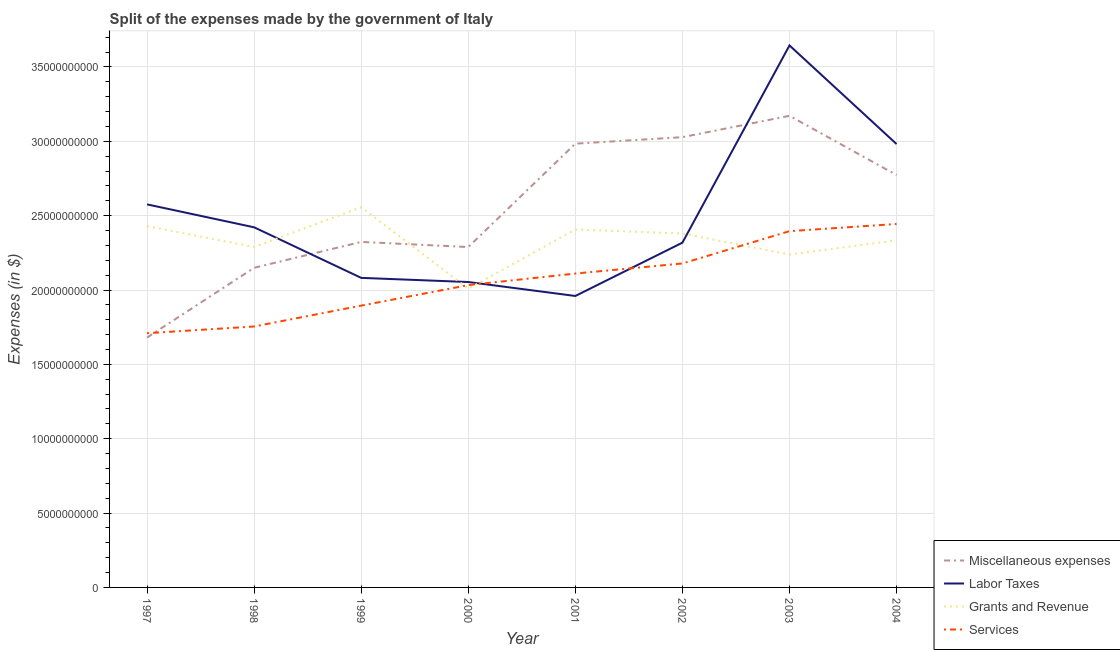Does the line corresponding to amount spent on miscellaneous expenses intersect with the line corresponding to amount spent on grants and revenue?
Ensure brevity in your answer.  Yes. Is the number of lines equal to the number of legend labels?
Your response must be concise. Yes. What is the amount spent on labor taxes in 2003?
Provide a short and direct response. 3.64e+1. Across all years, what is the maximum amount spent on miscellaneous expenses?
Offer a very short reply. 3.17e+1. Across all years, what is the minimum amount spent on grants and revenue?
Make the answer very short. 2.01e+1. In which year was the amount spent on miscellaneous expenses minimum?
Your response must be concise. 1997. What is the total amount spent on grants and revenue in the graph?
Make the answer very short. 1.86e+11. What is the difference between the amount spent on services in 1998 and that in 2001?
Offer a very short reply. -3.56e+09. What is the difference between the amount spent on miscellaneous expenses in 2000 and the amount spent on grants and revenue in 2001?
Make the answer very short. -1.18e+09. What is the average amount spent on labor taxes per year?
Provide a short and direct response. 2.50e+1. In the year 1999, what is the difference between the amount spent on services and amount spent on miscellaneous expenses?
Ensure brevity in your answer.  -4.28e+09. What is the ratio of the amount spent on miscellaneous expenses in 2000 to that in 2001?
Provide a short and direct response. 0.77. What is the difference between the highest and the second highest amount spent on services?
Keep it short and to the point. 4.83e+08. What is the difference between the highest and the lowest amount spent on grants and revenue?
Your answer should be very brief. 5.48e+09. Is the sum of the amount spent on miscellaneous expenses in 1999 and 2002 greater than the maximum amount spent on grants and revenue across all years?
Make the answer very short. Yes. Is it the case that in every year, the sum of the amount spent on grants and revenue and amount spent on services is greater than the sum of amount spent on labor taxes and amount spent on miscellaneous expenses?
Provide a succinct answer. No. Is the amount spent on miscellaneous expenses strictly less than the amount spent on services over the years?
Keep it short and to the point. No. How many lines are there?
Give a very brief answer. 4. How many years are there in the graph?
Offer a terse response. 8. Does the graph contain any zero values?
Offer a very short reply. No. Does the graph contain grids?
Ensure brevity in your answer.  Yes. How many legend labels are there?
Make the answer very short. 4. What is the title of the graph?
Offer a terse response. Split of the expenses made by the government of Italy. What is the label or title of the Y-axis?
Keep it short and to the point. Expenses (in $). What is the Expenses (in $) of Miscellaneous expenses in 1997?
Offer a terse response. 1.68e+1. What is the Expenses (in $) in Labor Taxes in 1997?
Keep it short and to the point. 2.58e+1. What is the Expenses (in $) in Grants and Revenue in 1997?
Give a very brief answer. 2.43e+1. What is the Expenses (in $) in Services in 1997?
Keep it short and to the point. 1.71e+1. What is the Expenses (in $) in Miscellaneous expenses in 1998?
Your response must be concise. 2.15e+1. What is the Expenses (in $) in Labor Taxes in 1998?
Ensure brevity in your answer.  2.42e+1. What is the Expenses (in $) of Grants and Revenue in 1998?
Offer a very short reply. 2.29e+1. What is the Expenses (in $) in Services in 1998?
Make the answer very short. 1.75e+1. What is the Expenses (in $) of Miscellaneous expenses in 1999?
Ensure brevity in your answer.  2.32e+1. What is the Expenses (in $) of Labor Taxes in 1999?
Your answer should be very brief. 2.08e+1. What is the Expenses (in $) of Grants and Revenue in 1999?
Provide a short and direct response. 2.56e+1. What is the Expenses (in $) in Services in 1999?
Ensure brevity in your answer.  1.89e+1. What is the Expenses (in $) in Miscellaneous expenses in 2000?
Offer a terse response. 2.29e+1. What is the Expenses (in $) in Labor Taxes in 2000?
Offer a very short reply. 2.05e+1. What is the Expenses (in $) in Grants and Revenue in 2000?
Offer a terse response. 2.01e+1. What is the Expenses (in $) of Services in 2000?
Ensure brevity in your answer.  2.03e+1. What is the Expenses (in $) of Miscellaneous expenses in 2001?
Your answer should be compact. 2.98e+1. What is the Expenses (in $) in Labor Taxes in 2001?
Offer a terse response. 1.96e+1. What is the Expenses (in $) in Grants and Revenue in 2001?
Provide a short and direct response. 2.41e+1. What is the Expenses (in $) in Services in 2001?
Offer a very short reply. 2.11e+1. What is the Expenses (in $) in Miscellaneous expenses in 2002?
Give a very brief answer. 3.03e+1. What is the Expenses (in $) of Labor Taxes in 2002?
Offer a very short reply. 2.32e+1. What is the Expenses (in $) of Grants and Revenue in 2002?
Give a very brief answer. 2.38e+1. What is the Expenses (in $) in Services in 2002?
Your response must be concise. 2.18e+1. What is the Expenses (in $) in Miscellaneous expenses in 2003?
Ensure brevity in your answer.  3.17e+1. What is the Expenses (in $) of Labor Taxes in 2003?
Provide a succinct answer. 3.64e+1. What is the Expenses (in $) of Grants and Revenue in 2003?
Your answer should be compact. 2.24e+1. What is the Expenses (in $) in Services in 2003?
Provide a succinct answer. 2.40e+1. What is the Expenses (in $) of Miscellaneous expenses in 2004?
Offer a terse response. 2.77e+1. What is the Expenses (in $) of Labor Taxes in 2004?
Offer a terse response. 2.98e+1. What is the Expenses (in $) in Grants and Revenue in 2004?
Make the answer very short. 2.33e+1. What is the Expenses (in $) of Services in 2004?
Keep it short and to the point. 2.44e+1. Across all years, what is the maximum Expenses (in $) in Miscellaneous expenses?
Your answer should be very brief. 3.17e+1. Across all years, what is the maximum Expenses (in $) of Labor Taxes?
Offer a terse response. 3.64e+1. Across all years, what is the maximum Expenses (in $) in Grants and Revenue?
Make the answer very short. 2.56e+1. Across all years, what is the maximum Expenses (in $) of Services?
Give a very brief answer. 2.44e+1. Across all years, what is the minimum Expenses (in $) in Miscellaneous expenses?
Your response must be concise. 1.68e+1. Across all years, what is the minimum Expenses (in $) of Labor Taxes?
Your answer should be very brief. 1.96e+1. Across all years, what is the minimum Expenses (in $) in Grants and Revenue?
Offer a terse response. 2.01e+1. Across all years, what is the minimum Expenses (in $) in Services?
Provide a short and direct response. 1.71e+1. What is the total Expenses (in $) in Miscellaneous expenses in the graph?
Keep it short and to the point. 2.04e+11. What is the total Expenses (in $) of Labor Taxes in the graph?
Keep it short and to the point. 2.00e+11. What is the total Expenses (in $) in Grants and Revenue in the graph?
Offer a very short reply. 1.86e+11. What is the total Expenses (in $) in Services in the graph?
Give a very brief answer. 1.65e+11. What is the difference between the Expenses (in $) in Miscellaneous expenses in 1997 and that in 1998?
Your response must be concise. -4.69e+09. What is the difference between the Expenses (in $) of Labor Taxes in 1997 and that in 1998?
Ensure brevity in your answer.  1.54e+09. What is the difference between the Expenses (in $) of Grants and Revenue in 1997 and that in 1998?
Ensure brevity in your answer.  1.40e+09. What is the difference between the Expenses (in $) in Services in 1997 and that in 1998?
Offer a terse response. -4.52e+08. What is the difference between the Expenses (in $) in Miscellaneous expenses in 1997 and that in 1999?
Provide a short and direct response. -6.43e+09. What is the difference between the Expenses (in $) of Labor Taxes in 1997 and that in 1999?
Offer a terse response. 4.94e+09. What is the difference between the Expenses (in $) of Grants and Revenue in 1997 and that in 1999?
Your response must be concise. -1.27e+09. What is the difference between the Expenses (in $) of Services in 1997 and that in 1999?
Keep it short and to the point. -1.85e+09. What is the difference between the Expenses (in $) of Miscellaneous expenses in 1997 and that in 2000?
Ensure brevity in your answer.  -6.08e+09. What is the difference between the Expenses (in $) in Labor Taxes in 1997 and that in 2000?
Your response must be concise. 5.22e+09. What is the difference between the Expenses (in $) of Grants and Revenue in 1997 and that in 2000?
Your answer should be very brief. 4.21e+09. What is the difference between the Expenses (in $) in Services in 1997 and that in 2000?
Your answer should be compact. -3.23e+09. What is the difference between the Expenses (in $) in Miscellaneous expenses in 1997 and that in 2001?
Provide a short and direct response. -1.30e+1. What is the difference between the Expenses (in $) of Labor Taxes in 1997 and that in 2001?
Provide a short and direct response. 6.16e+09. What is the difference between the Expenses (in $) in Grants and Revenue in 1997 and that in 2001?
Make the answer very short. 2.26e+08. What is the difference between the Expenses (in $) in Services in 1997 and that in 2001?
Offer a very short reply. -4.01e+09. What is the difference between the Expenses (in $) of Miscellaneous expenses in 1997 and that in 2002?
Offer a very short reply. -1.35e+1. What is the difference between the Expenses (in $) in Labor Taxes in 1997 and that in 2002?
Your answer should be very brief. 2.57e+09. What is the difference between the Expenses (in $) in Grants and Revenue in 1997 and that in 2002?
Keep it short and to the point. 4.95e+08. What is the difference between the Expenses (in $) in Services in 1997 and that in 2002?
Ensure brevity in your answer.  -4.69e+09. What is the difference between the Expenses (in $) of Miscellaneous expenses in 1997 and that in 2003?
Offer a terse response. -1.49e+1. What is the difference between the Expenses (in $) of Labor Taxes in 1997 and that in 2003?
Your response must be concise. -1.07e+1. What is the difference between the Expenses (in $) in Grants and Revenue in 1997 and that in 2003?
Your response must be concise. 1.92e+09. What is the difference between the Expenses (in $) in Services in 1997 and that in 2003?
Your answer should be very brief. -6.86e+09. What is the difference between the Expenses (in $) in Miscellaneous expenses in 1997 and that in 2004?
Keep it short and to the point. -1.09e+1. What is the difference between the Expenses (in $) of Labor Taxes in 1997 and that in 2004?
Your answer should be compact. -4.06e+09. What is the difference between the Expenses (in $) of Grants and Revenue in 1997 and that in 2004?
Offer a terse response. 9.54e+08. What is the difference between the Expenses (in $) of Services in 1997 and that in 2004?
Your response must be concise. -7.34e+09. What is the difference between the Expenses (in $) in Miscellaneous expenses in 1998 and that in 1999?
Your response must be concise. -1.74e+09. What is the difference between the Expenses (in $) in Labor Taxes in 1998 and that in 1999?
Give a very brief answer. 3.40e+09. What is the difference between the Expenses (in $) in Grants and Revenue in 1998 and that in 1999?
Give a very brief answer. -2.67e+09. What is the difference between the Expenses (in $) in Services in 1998 and that in 1999?
Provide a short and direct response. -1.40e+09. What is the difference between the Expenses (in $) of Miscellaneous expenses in 1998 and that in 2000?
Offer a very short reply. -1.40e+09. What is the difference between the Expenses (in $) in Labor Taxes in 1998 and that in 2000?
Your response must be concise. 3.68e+09. What is the difference between the Expenses (in $) in Grants and Revenue in 1998 and that in 2000?
Ensure brevity in your answer.  2.80e+09. What is the difference between the Expenses (in $) of Services in 1998 and that in 2000?
Make the answer very short. -2.78e+09. What is the difference between the Expenses (in $) of Miscellaneous expenses in 1998 and that in 2001?
Ensure brevity in your answer.  -8.35e+09. What is the difference between the Expenses (in $) of Labor Taxes in 1998 and that in 2001?
Offer a very short reply. 4.62e+09. What is the difference between the Expenses (in $) in Grants and Revenue in 1998 and that in 2001?
Give a very brief answer. -1.18e+09. What is the difference between the Expenses (in $) in Services in 1998 and that in 2001?
Provide a short and direct response. -3.56e+09. What is the difference between the Expenses (in $) in Miscellaneous expenses in 1998 and that in 2002?
Offer a terse response. -8.78e+09. What is the difference between the Expenses (in $) in Labor Taxes in 1998 and that in 2002?
Provide a succinct answer. 1.03e+09. What is the difference between the Expenses (in $) of Grants and Revenue in 1998 and that in 2002?
Make the answer very short. -9.10e+08. What is the difference between the Expenses (in $) in Services in 1998 and that in 2002?
Make the answer very short. -4.24e+09. What is the difference between the Expenses (in $) of Miscellaneous expenses in 1998 and that in 2003?
Offer a very short reply. -1.02e+1. What is the difference between the Expenses (in $) of Labor Taxes in 1998 and that in 2003?
Give a very brief answer. -1.22e+1. What is the difference between the Expenses (in $) in Grants and Revenue in 1998 and that in 2003?
Make the answer very short. 5.10e+08. What is the difference between the Expenses (in $) in Services in 1998 and that in 2003?
Ensure brevity in your answer.  -6.41e+09. What is the difference between the Expenses (in $) in Miscellaneous expenses in 1998 and that in 2004?
Make the answer very short. -6.24e+09. What is the difference between the Expenses (in $) of Labor Taxes in 1998 and that in 2004?
Provide a succinct answer. -5.60e+09. What is the difference between the Expenses (in $) of Grants and Revenue in 1998 and that in 2004?
Offer a terse response. -4.51e+08. What is the difference between the Expenses (in $) in Services in 1998 and that in 2004?
Your answer should be compact. -6.89e+09. What is the difference between the Expenses (in $) in Miscellaneous expenses in 1999 and that in 2000?
Give a very brief answer. 3.44e+08. What is the difference between the Expenses (in $) in Labor Taxes in 1999 and that in 2000?
Ensure brevity in your answer.  2.78e+08. What is the difference between the Expenses (in $) in Grants and Revenue in 1999 and that in 2000?
Offer a terse response. 5.48e+09. What is the difference between the Expenses (in $) of Services in 1999 and that in 2000?
Offer a terse response. -1.38e+09. What is the difference between the Expenses (in $) in Miscellaneous expenses in 1999 and that in 2001?
Your response must be concise. -6.61e+09. What is the difference between the Expenses (in $) in Labor Taxes in 1999 and that in 2001?
Make the answer very short. 1.22e+09. What is the difference between the Expenses (in $) in Grants and Revenue in 1999 and that in 2001?
Keep it short and to the point. 1.49e+09. What is the difference between the Expenses (in $) in Services in 1999 and that in 2001?
Offer a very short reply. -2.16e+09. What is the difference between the Expenses (in $) in Miscellaneous expenses in 1999 and that in 2002?
Keep it short and to the point. -7.04e+09. What is the difference between the Expenses (in $) of Labor Taxes in 1999 and that in 2002?
Make the answer very short. -2.37e+09. What is the difference between the Expenses (in $) in Grants and Revenue in 1999 and that in 2002?
Ensure brevity in your answer.  1.76e+09. What is the difference between the Expenses (in $) in Services in 1999 and that in 2002?
Provide a short and direct response. -2.84e+09. What is the difference between the Expenses (in $) of Miscellaneous expenses in 1999 and that in 2003?
Ensure brevity in your answer.  -8.48e+09. What is the difference between the Expenses (in $) in Labor Taxes in 1999 and that in 2003?
Make the answer very short. -1.56e+1. What is the difference between the Expenses (in $) in Grants and Revenue in 1999 and that in 2003?
Make the answer very short. 3.18e+09. What is the difference between the Expenses (in $) in Services in 1999 and that in 2003?
Provide a succinct answer. -5.01e+09. What is the difference between the Expenses (in $) in Miscellaneous expenses in 1999 and that in 2004?
Your answer should be very brief. -4.50e+09. What is the difference between the Expenses (in $) in Labor Taxes in 1999 and that in 2004?
Offer a very short reply. -9.00e+09. What is the difference between the Expenses (in $) in Grants and Revenue in 1999 and that in 2004?
Provide a succinct answer. 2.22e+09. What is the difference between the Expenses (in $) of Services in 1999 and that in 2004?
Offer a very short reply. -5.49e+09. What is the difference between the Expenses (in $) of Miscellaneous expenses in 2000 and that in 2001?
Ensure brevity in your answer.  -6.95e+09. What is the difference between the Expenses (in $) of Labor Taxes in 2000 and that in 2001?
Your answer should be compact. 9.39e+08. What is the difference between the Expenses (in $) of Grants and Revenue in 2000 and that in 2001?
Offer a very short reply. -3.98e+09. What is the difference between the Expenses (in $) of Services in 2000 and that in 2001?
Offer a terse response. -7.77e+08. What is the difference between the Expenses (in $) of Miscellaneous expenses in 2000 and that in 2002?
Your answer should be compact. -7.39e+09. What is the difference between the Expenses (in $) of Labor Taxes in 2000 and that in 2002?
Provide a short and direct response. -2.65e+09. What is the difference between the Expenses (in $) of Grants and Revenue in 2000 and that in 2002?
Provide a short and direct response. -3.72e+09. What is the difference between the Expenses (in $) of Services in 2000 and that in 2002?
Give a very brief answer. -1.46e+09. What is the difference between the Expenses (in $) in Miscellaneous expenses in 2000 and that in 2003?
Offer a very short reply. -8.82e+09. What is the difference between the Expenses (in $) in Labor Taxes in 2000 and that in 2003?
Provide a short and direct response. -1.59e+1. What is the difference between the Expenses (in $) in Grants and Revenue in 2000 and that in 2003?
Offer a terse response. -2.30e+09. What is the difference between the Expenses (in $) of Services in 2000 and that in 2003?
Provide a succinct answer. -3.63e+09. What is the difference between the Expenses (in $) in Miscellaneous expenses in 2000 and that in 2004?
Offer a terse response. -4.84e+09. What is the difference between the Expenses (in $) of Labor Taxes in 2000 and that in 2004?
Your response must be concise. -9.28e+09. What is the difference between the Expenses (in $) of Grants and Revenue in 2000 and that in 2004?
Keep it short and to the point. -3.26e+09. What is the difference between the Expenses (in $) of Services in 2000 and that in 2004?
Make the answer very short. -4.11e+09. What is the difference between the Expenses (in $) in Miscellaneous expenses in 2001 and that in 2002?
Your answer should be very brief. -4.36e+08. What is the difference between the Expenses (in $) in Labor Taxes in 2001 and that in 2002?
Keep it short and to the point. -3.59e+09. What is the difference between the Expenses (in $) of Grants and Revenue in 2001 and that in 2002?
Your answer should be very brief. 2.69e+08. What is the difference between the Expenses (in $) of Services in 2001 and that in 2002?
Make the answer very short. -6.79e+08. What is the difference between the Expenses (in $) in Miscellaneous expenses in 2001 and that in 2003?
Give a very brief answer. -1.87e+09. What is the difference between the Expenses (in $) in Labor Taxes in 2001 and that in 2003?
Your answer should be very brief. -1.68e+1. What is the difference between the Expenses (in $) in Grants and Revenue in 2001 and that in 2003?
Keep it short and to the point. 1.69e+09. What is the difference between the Expenses (in $) in Services in 2001 and that in 2003?
Offer a very short reply. -2.85e+09. What is the difference between the Expenses (in $) of Miscellaneous expenses in 2001 and that in 2004?
Offer a very short reply. 2.11e+09. What is the difference between the Expenses (in $) in Labor Taxes in 2001 and that in 2004?
Your answer should be very brief. -1.02e+1. What is the difference between the Expenses (in $) of Grants and Revenue in 2001 and that in 2004?
Give a very brief answer. 7.28e+08. What is the difference between the Expenses (in $) of Services in 2001 and that in 2004?
Offer a terse response. -3.33e+09. What is the difference between the Expenses (in $) in Miscellaneous expenses in 2002 and that in 2003?
Your response must be concise. -1.44e+09. What is the difference between the Expenses (in $) of Labor Taxes in 2002 and that in 2003?
Offer a terse response. -1.33e+1. What is the difference between the Expenses (in $) of Grants and Revenue in 2002 and that in 2003?
Provide a short and direct response. 1.42e+09. What is the difference between the Expenses (in $) of Services in 2002 and that in 2003?
Provide a succinct answer. -2.17e+09. What is the difference between the Expenses (in $) in Miscellaneous expenses in 2002 and that in 2004?
Provide a short and direct response. 2.55e+09. What is the difference between the Expenses (in $) in Labor Taxes in 2002 and that in 2004?
Offer a very short reply. -6.63e+09. What is the difference between the Expenses (in $) of Grants and Revenue in 2002 and that in 2004?
Offer a very short reply. 4.59e+08. What is the difference between the Expenses (in $) of Services in 2002 and that in 2004?
Keep it short and to the point. -2.66e+09. What is the difference between the Expenses (in $) of Miscellaneous expenses in 2003 and that in 2004?
Your answer should be compact. 3.98e+09. What is the difference between the Expenses (in $) in Labor Taxes in 2003 and that in 2004?
Your answer should be compact. 6.63e+09. What is the difference between the Expenses (in $) in Grants and Revenue in 2003 and that in 2004?
Provide a succinct answer. -9.61e+08. What is the difference between the Expenses (in $) in Services in 2003 and that in 2004?
Your answer should be very brief. -4.83e+08. What is the difference between the Expenses (in $) of Miscellaneous expenses in 1997 and the Expenses (in $) of Labor Taxes in 1998?
Make the answer very short. -7.41e+09. What is the difference between the Expenses (in $) of Miscellaneous expenses in 1997 and the Expenses (in $) of Grants and Revenue in 1998?
Your answer should be compact. -6.09e+09. What is the difference between the Expenses (in $) in Miscellaneous expenses in 1997 and the Expenses (in $) in Services in 1998?
Keep it short and to the point. -7.42e+08. What is the difference between the Expenses (in $) of Labor Taxes in 1997 and the Expenses (in $) of Grants and Revenue in 1998?
Offer a very short reply. 2.86e+09. What is the difference between the Expenses (in $) of Labor Taxes in 1997 and the Expenses (in $) of Services in 1998?
Ensure brevity in your answer.  8.21e+09. What is the difference between the Expenses (in $) of Grants and Revenue in 1997 and the Expenses (in $) of Services in 1998?
Give a very brief answer. 6.75e+09. What is the difference between the Expenses (in $) in Miscellaneous expenses in 1997 and the Expenses (in $) in Labor Taxes in 1999?
Offer a terse response. -4.01e+09. What is the difference between the Expenses (in $) of Miscellaneous expenses in 1997 and the Expenses (in $) of Grants and Revenue in 1999?
Offer a terse response. -8.76e+09. What is the difference between the Expenses (in $) of Miscellaneous expenses in 1997 and the Expenses (in $) of Services in 1999?
Keep it short and to the point. -2.14e+09. What is the difference between the Expenses (in $) in Labor Taxes in 1997 and the Expenses (in $) in Grants and Revenue in 1999?
Offer a terse response. 1.92e+08. What is the difference between the Expenses (in $) in Labor Taxes in 1997 and the Expenses (in $) in Services in 1999?
Offer a terse response. 6.81e+09. What is the difference between the Expenses (in $) in Grants and Revenue in 1997 and the Expenses (in $) in Services in 1999?
Make the answer very short. 5.35e+09. What is the difference between the Expenses (in $) in Miscellaneous expenses in 1997 and the Expenses (in $) in Labor Taxes in 2000?
Your response must be concise. -3.73e+09. What is the difference between the Expenses (in $) in Miscellaneous expenses in 1997 and the Expenses (in $) in Grants and Revenue in 2000?
Your response must be concise. -3.28e+09. What is the difference between the Expenses (in $) of Miscellaneous expenses in 1997 and the Expenses (in $) of Services in 2000?
Your response must be concise. -3.52e+09. What is the difference between the Expenses (in $) in Labor Taxes in 1997 and the Expenses (in $) in Grants and Revenue in 2000?
Keep it short and to the point. 5.67e+09. What is the difference between the Expenses (in $) of Labor Taxes in 1997 and the Expenses (in $) of Services in 2000?
Make the answer very short. 5.43e+09. What is the difference between the Expenses (in $) in Grants and Revenue in 1997 and the Expenses (in $) in Services in 2000?
Provide a succinct answer. 3.97e+09. What is the difference between the Expenses (in $) in Miscellaneous expenses in 1997 and the Expenses (in $) in Labor Taxes in 2001?
Your response must be concise. -2.79e+09. What is the difference between the Expenses (in $) in Miscellaneous expenses in 1997 and the Expenses (in $) in Grants and Revenue in 2001?
Offer a very short reply. -7.27e+09. What is the difference between the Expenses (in $) of Miscellaneous expenses in 1997 and the Expenses (in $) of Services in 2001?
Ensure brevity in your answer.  -4.30e+09. What is the difference between the Expenses (in $) in Labor Taxes in 1997 and the Expenses (in $) in Grants and Revenue in 2001?
Provide a short and direct response. 1.69e+09. What is the difference between the Expenses (in $) of Labor Taxes in 1997 and the Expenses (in $) of Services in 2001?
Your answer should be very brief. 4.65e+09. What is the difference between the Expenses (in $) in Grants and Revenue in 1997 and the Expenses (in $) in Services in 2001?
Make the answer very short. 3.19e+09. What is the difference between the Expenses (in $) in Miscellaneous expenses in 1997 and the Expenses (in $) in Labor Taxes in 2002?
Your answer should be very brief. -6.38e+09. What is the difference between the Expenses (in $) of Miscellaneous expenses in 1997 and the Expenses (in $) of Grants and Revenue in 2002?
Your response must be concise. -7.00e+09. What is the difference between the Expenses (in $) in Miscellaneous expenses in 1997 and the Expenses (in $) in Services in 2002?
Make the answer very short. -4.98e+09. What is the difference between the Expenses (in $) of Labor Taxes in 1997 and the Expenses (in $) of Grants and Revenue in 2002?
Make the answer very short. 1.96e+09. What is the difference between the Expenses (in $) in Labor Taxes in 1997 and the Expenses (in $) in Services in 2002?
Provide a short and direct response. 3.97e+09. What is the difference between the Expenses (in $) in Grants and Revenue in 1997 and the Expenses (in $) in Services in 2002?
Make the answer very short. 2.51e+09. What is the difference between the Expenses (in $) of Miscellaneous expenses in 1997 and the Expenses (in $) of Labor Taxes in 2003?
Your answer should be compact. -1.96e+1. What is the difference between the Expenses (in $) of Miscellaneous expenses in 1997 and the Expenses (in $) of Grants and Revenue in 2003?
Provide a succinct answer. -5.58e+09. What is the difference between the Expenses (in $) of Miscellaneous expenses in 1997 and the Expenses (in $) of Services in 2003?
Make the answer very short. -7.15e+09. What is the difference between the Expenses (in $) of Labor Taxes in 1997 and the Expenses (in $) of Grants and Revenue in 2003?
Make the answer very short. 3.38e+09. What is the difference between the Expenses (in $) in Labor Taxes in 1997 and the Expenses (in $) in Services in 2003?
Make the answer very short. 1.80e+09. What is the difference between the Expenses (in $) of Grants and Revenue in 1997 and the Expenses (in $) of Services in 2003?
Offer a very short reply. 3.40e+08. What is the difference between the Expenses (in $) in Miscellaneous expenses in 1997 and the Expenses (in $) in Labor Taxes in 2004?
Ensure brevity in your answer.  -1.30e+1. What is the difference between the Expenses (in $) in Miscellaneous expenses in 1997 and the Expenses (in $) in Grants and Revenue in 2004?
Make the answer very short. -6.54e+09. What is the difference between the Expenses (in $) of Miscellaneous expenses in 1997 and the Expenses (in $) of Services in 2004?
Offer a terse response. -7.64e+09. What is the difference between the Expenses (in $) of Labor Taxes in 1997 and the Expenses (in $) of Grants and Revenue in 2004?
Your response must be concise. 2.41e+09. What is the difference between the Expenses (in $) in Labor Taxes in 1997 and the Expenses (in $) in Services in 2004?
Make the answer very short. 1.32e+09. What is the difference between the Expenses (in $) of Grants and Revenue in 1997 and the Expenses (in $) of Services in 2004?
Offer a very short reply. -1.43e+08. What is the difference between the Expenses (in $) in Miscellaneous expenses in 1998 and the Expenses (in $) in Labor Taxes in 1999?
Give a very brief answer. 6.79e+08. What is the difference between the Expenses (in $) in Miscellaneous expenses in 1998 and the Expenses (in $) in Grants and Revenue in 1999?
Ensure brevity in your answer.  -4.07e+09. What is the difference between the Expenses (in $) in Miscellaneous expenses in 1998 and the Expenses (in $) in Services in 1999?
Provide a succinct answer. 2.54e+09. What is the difference between the Expenses (in $) of Labor Taxes in 1998 and the Expenses (in $) of Grants and Revenue in 1999?
Your answer should be compact. -1.35e+09. What is the difference between the Expenses (in $) of Labor Taxes in 1998 and the Expenses (in $) of Services in 1999?
Provide a succinct answer. 5.27e+09. What is the difference between the Expenses (in $) in Grants and Revenue in 1998 and the Expenses (in $) in Services in 1999?
Ensure brevity in your answer.  3.94e+09. What is the difference between the Expenses (in $) of Miscellaneous expenses in 1998 and the Expenses (in $) of Labor Taxes in 2000?
Provide a short and direct response. 9.57e+08. What is the difference between the Expenses (in $) in Miscellaneous expenses in 1998 and the Expenses (in $) in Grants and Revenue in 2000?
Give a very brief answer. 1.41e+09. What is the difference between the Expenses (in $) in Miscellaneous expenses in 1998 and the Expenses (in $) in Services in 2000?
Your answer should be compact. 1.16e+09. What is the difference between the Expenses (in $) in Labor Taxes in 1998 and the Expenses (in $) in Grants and Revenue in 2000?
Ensure brevity in your answer.  4.13e+09. What is the difference between the Expenses (in $) of Labor Taxes in 1998 and the Expenses (in $) of Services in 2000?
Keep it short and to the point. 3.89e+09. What is the difference between the Expenses (in $) in Grants and Revenue in 1998 and the Expenses (in $) in Services in 2000?
Ensure brevity in your answer.  2.56e+09. What is the difference between the Expenses (in $) of Miscellaneous expenses in 1998 and the Expenses (in $) of Labor Taxes in 2001?
Offer a very short reply. 1.90e+09. What is the difference between the Expenses (in $) of Miscellaneous expenses in 1998 and the Expenses (in $) of Grants and Revenue in 2001?
Keep it short and to the point. -2.58e+09. What is the difference between the Expenses (in $) in Miscellaneous expenses in 1998 and the Expenses (in $) in Services in 2001?
Your answer should be compact. 3.88e+08. What is the difference between the Expenses (in $) of Labor Taxes in 1998 and the Expenses (in $) of Grants and Revenue in 2001?
Offer a very short reply. 1.44e+08. What is the difference between the Expenses (in $) in Labor Taxes in 1998 and the Expenses (in $) in Services in 2001?
Offer a terse response. 3.11e+09. What is the difference between the Expenses (in $) in Grants and Revenue in 1998 and the Expenses (in $) in Services in 2001?
Your answer should be very brief. 1.79e+09. What is the difference between the Expenses (in $) of Miscellaneous expenses in 1998 and the Expenses (in $) of Labor Taxes in 2002?
Offer a terse response. -1.69e+09. What is the difference between the Expenses (in $) of Miscellaneous expenses in 1998 and the Expenses (in $) of Grants and Revenue in 2002?
Provide a succinct answer. -2.31e+09. What is the difference between the Expenses (in $) of Miscellaneous expenses in 1998 and the Expenses (in $) of Services in 2002?
Keep it short and to the point. -2.91e+08. What is the difference between the Expenses (in $) in Labor Taxes in 1998 and the Expenses (in $) in Grants and Revenue in 2002?
Your answer should be compact. 4.13e+08. What is the difference between the Expenses (in $) in Labor Taxes in 1998 and the Expenses (in $) in Services in 2002?
Offer a very short reply. 2.43e+09. What is the difference between the Expenses (in $) of Grants and Revenue in 1998 and the Expenses (in $) of Services in 2002?
Offer a very short reply. 1.11e+09. What is the difference between the Expenses (in $) in Miscellaneous expenses in 1998 and the Expenses (in $) in Labor Taxes in 2003?
Your answer should be compact. -1.50e+1. What is the difference between the Expenses (in $) in Miscellaneous expenses in 1998 and the Expenses (in $) in Grants and Revenue in 2003?
Keep it short and to the point. -8.88e+08. What is the difference between the Expenses (in $) of Miscellaneous expenses in 1998 and the Expenses (in $) of Services in 2003?
Your answer should be compact. -2.46e+09. What is the difference between the Expenses (in $) in Labor Taxes in 1998 and the Expenses (in $) in Grants and Revenue in 2003?
Give a very brief answer. 1.83e+09. What is the difference between the Expenses (in $) of Labor Taxes in 1998 and the Expenses (in $) of Services in 2003?
Offer a terse response. 2.58e+08. What is the difference between the Expenses (in $) in Grants and Revenue in 1998 and the Expenses (in $) in Services in 2003?
Keep it short and to the point. -1.06e+09. What is the difference between the Expenses (in $) in Miscellaneous expenses in 1998 and the Expenses (in $) in Labor Taxes in 2004?
Your answer should be very brief. -8.32e+09. What is the difference between the Expenses (in $) of Miscellaneous expenses in 1998 and the Expenses (in $) of Grants and Revenue in 2004?
Give a very brief answer. -1.85e+09. What is the difference between the Expenses (in $) of Miscellaneous expenses in 1998 and the Expenses (in $) of Services in 2004?
Your response must be concise. -2.95e+09. What is the difference between the Expenses (in $) in Labor Taxes in 1998 and the Expenses (in $) in Grants and Revenue in 2004?
Offer a very short reply. 8.72e+08. What is the difference between the Expenses (in $) in Labor Taxes in 1998 and the Expenses (in $) in Services in 2004?
Keep it short and to the point. -2.25e+08. What is the difference between the Expenses (in $) of Grants and Revenue in 1998 and the Expenses (in $) of Services in 2004?
Your response must be concise. -1.55e+09. What is the difference between the Expenses (in $) of Miscellaneous expenses in 1999 and the Expenses (in $) of Labor Taxes in 2000?
Make the answer very short. 2.70e+09. What is the difference between the Expenses (in $) of Miscellaneous expenses in 1999 and the Expenses (in $) of Grants and Revenue in 2000?
Make the answer very short. 3.15e+09. What is the difference between the Expenses (in $) of Miscellaneous expenses in 1999 and the Expenses (in $) of Services in 2000?
Your answer should be compact. 2.90e+09. What is the difference between the Expenses (in $) in Labor Taxes in 1999 and the Expenses (in $) in Grants and Revenue in 2000?
Ensure brevity in your answer.  7.28e+08. What is the difference between the Expenses (in $) of Labor Taxes in 1999 and the Expenses (in $) of Services in 2000?
Offer a very short reply. 4.86e+08. What is the difference between the Expenses (in $) in Grants and Revenue in 1999 and the Expenses (in $) in Services in 2000?
Make the answer very short. 5.24e+09. What is the difference between the Expenses (in $) in Miscellaneous expenses in 1999 and the Expenses (in $) in Labor Taxes in 2001?
Keep it short and to the point. 3.64e+09. What is the difference between the Expenses (in $) in Miscellaneous expenses in 1999 and the Expenses (in $) in Grants and Revenue in 2001?
Your answer should be compact. -8.38e+08. What is the difference between the Expenses (in $) in Miscellaneous expenses in 1999 and the Expenses (in $) in Services in 2001?
Offer a very short reply. 2.13e+09. What is the difference between the Expenses (in $) of Labor Taxes in 1999 and the Expenses (in $) of Grants and Revenue in 2001?
Provide a short and direct response. -3.26e+09. What is the difference between the Expenses (in $) of Labor Taxes in 1999 and the Expenses (in $) of Services in 2001?
Provide a short and direct response. -2.91e+08. What is the difference between the Expenses (in $) in Grants and Revenue in 1999 and the Expenses (in $) in Services in 2001?
Give a very brief answer. 4.46e+09. What is the difference between the Expenses (in $) in Miscellaneous expenses in 1999 and the Expenses (in $) in Labor Taxes in 2002?
Your answer should be compact. 4.90e+07. What is the difference between the Expenses (in $) of Miscellaneous expenses in 1999 and the Expenses (in $) of Grants and Revenue in 2002?
Provide a short and direct response. -5.69e+08. What is the difference between the Expenses (in $) of Miscellaneous expenses in 1999 and the Expenses (in $) of Services in 2002?
Make the answer very short. 1.45e+09. What is the difference between the Expenses (in $) in Labor Taxes in 1999 and the Expenses (in $) in Grants and Revenue in 2002?
Offer a terse response. -2.99e+09. What is the difference between the Expenses (in $) of Labor Taxes in 1999 and the Expenses (in $) of Services in 2002?
Your answer should be compact. -9.70e+08. What is the difference between the Expenses (in $) of Grants and Revenue in 1999 and the Expenses (in $) of Services in 2002?
Offer a terse response. 3.78e+09. What is the difference between the Expenses (in $) of Miscellaneous expenses in 1999 and the Expenses (in $) of Labor Taxes in 2003?
Provide a succinct answer. -1.32e+1. What is the difference between the Expenses (in $) in Miscellaneous expenses in 1999 and the Expenses (in $) in Grants and Revenue in 2003?
Your response must be concise. 8.51e+08. What is the difference between the Expenses (in $) in Miscellaneous expenses in 1999 and the Expenses (in $) in Services in 2003?
Provide a succinct answer. -7.24e+08. What is the difference between the Expenses (in $) of Labor Taxes in 1999 and the Expenses (in $) of Grants and Revenue in 2003?
Offer a terse response. -1.57e+09. What is the difference between the Expenses (in $) of Labor Taxes in 1999 and the Expenses (in $) of Services in 2003?
Offer a terse response. -3.14e+09. What is the difference between the Expenses (in $) in Grants and Revenue in 1999 and the Expenses (in $) in Services in 2003?
Make the answer very short. 1.61e+09. What is the difference between the Expenses (in $) in Miscellaneous expenses in 1999 and the Expenses (in $) in Labor Taxes in 2004?
Make the answer very short. -6.58e+09. What is the difference between the Expenses (in $) in Miscellaneous expenses in 1999 and the Expenses (in $) in Grants and Revenue in 2004?
Keep it short and to the point. -1.10e+08. What is the difference between the Expenses (in $) of Miscellaneous expenses in 1999 and the Expenses (in $) of Services in 2004?
Your answer should be very brief. -1.21e+09. What is the difference between the Expenses (in $) in Labor Taxes in 1999 and the Expenses (in $) in Grants and Revenue in 2004?
Provide a short and direct response. -2.53e+09. What is the difference between the Expenses (in $) of Labor Taxes in 1999 and the Expenses (in $) of Services in 2004?
Ensure brevity in your answer.  -3.62e+09. What is the difference between the Expenses (in $) of Grants and Revenue in 1999 and the Expenses (in $) of Services in 2004?
Give a very brief answer. 1.12e+09. What is the difference between the Expenses (in $) in Miscellaneous expenses in 2000 and the Expenses (in $) in Labor Taxes in 2001?
Provide a succinct answer. 3.29e+09. What is the difference between the Expenses (in $) of Miscellaneous expenses in 2000 and the Expenses (in $) of Grants and Revenue in 2001?
Keep it short and to the point. -1.18e+09. What is the difference between the Expenses (in $) in Miscellaneous expenses in 2000 and the Expenses (in $) in Services in 2001?
Offer a very short reply. 1.78e+09. What is the difference between the Expenses (in $) in Labor Taxes in 2000 and the Expenses (in $) in Grants and Revenue in 2001?
Keep it short and to the point. -3.53e+09. What is the difference between the Expenses (in $) of Labor Taxes in 2000 and the Expenses (in $) of Services in 2001?
Provide a short and direct response. -5.69e+08. What is the difference between the Expenses (in $) in Grants and Revenue in 2000 and the Expenses (in $) in Services in 2001?
Provide a succinct answer. -1.02e+09. What is the difference between the Expenses (in $) in Miscellaneous expenses in 2000 and the Expenses (in $) in Labor Taxes in 2002?
Provide a succinct answer. -2.95e+08. What is the difference between the Expenses (in $) of Miscellaneous expenses in 2000 and the Expenses (in $) of Grants and Revenue in 2002?
Your response must be concise. -9.13e+08. What is the difference between the Expenses (in $) in Miscellaneous expenses in 2000 and the Expenses (in $) in Services in 2002?
Ensure brevity in your answer.  1.10e+09. What is the difference between the Expenses (in $) of Labor Taxes in 2000 and the Expenses (in $) of Grants and Revenue in 2002?
Your response must be concise. -3.26e+09. What is the difference between the Expenses (in $) of Labor Taxes in 2000 and the Expenses (in $) of Services in 2002?
Provide a short and direct response. -1.25e+09. What is the difference between the Expenses (in $) in Grants and Revenue in 2000 and the Expenses (in $) in Services in 2002?
Give a very brief answer. -1.70e+09. What is the difference between the Expenses (in $) in Miscellaneous expenses in 2000 and the Expenses (in $) in Labor Taxes in 2003?
Offer a very short reply. -1.36e+1. What is the difference between the Expenses (in $) of Miscellaneous expenses in 2000 and the Expenses (in $) of Grants and Revenue in 2003?
Your answer should be very brief. 5.07e+08. What is the difference between the Expenses (in $) in Miscellaneous expenses in 2000 and the Expenses (in $) in Services in 2003?
Provide a short and direct response. -1.07e+09. What is the difference between the Expenses (in $) of Labor Taxes in 2000 and the Expenses (in $) of Grants and Revenue in 2003?
Provide a succinct answer. -1.84e+09. What is the difference between the Expenses (in $) of Labor Taxes in 2000 and the Expenses (in $) of Services in 2003?
Ensure brevity in your answer.  -3.42e+09. What is the difference between the Expenses (in $) in Grants and Revenue in 2000 and the Expenses (in $) in Services in 2003?
Provide a succinct answer. -3.87e+09. What is the difference between the Expenses (in $) in Miscellaneous expenses in 2000 and the Expenses (in $) in Labor Taxes in 2004?
Keep it short and to the point. -6.93e+09. What is the difference between the Expenses (in $) in Miscellaneous expenses in 2000 and the Expenses (in $) in Grants and Revenue in 2004?
Ensure brevity in your answer.  -4.54e+08. What is the difference between the Expenses (in $) in Miscellaneous expenses in 2000 and the Expenses (in $) in Services in 2004?
Ensure brevity in your answer.  -1.55e+09. What is the difference between the Expenses (in $) in Labor Taxes in 2000 and the Expenses (in $) in Grants and Revenue in 2004?
Provide a short and direct response. -2.81e+09. What is the difference between the Expenses (in $) in Labor Taxes in 2000 and the Expenses (in $) in Services in 2004?
Provide a short and direct response. -3.90e+09. What is the difference between the Expenses (in $) in Grants and Revenue in 2000 and the Expenses (in $) in Services in 2004?
Offer a terse response. -4.35e+09. What is the difference between the Expenses (in $) of Miscellaneous expenses in 2001 and the Expenses (in $) of Labor Taxes in 2002?
Your answer should be very brief. 6.66e+09. What is the difference between the Expenses (in $) in Miscellaneous expenses in 2001 and the Expenses (in $) in Grants and Revenue in 2002?
Make the answer very short. 6.04e+09. What is the difference between the Expenses (in $) of Miscellaneous expenses in 2001 and the Expenses (in $) of Services in 2002?
Provide a succinct answer. 8.06e+09. What is the difference between the Expenses (in $) of Labor Taxes in 2001 and the Expenses (in $) of Grants and Revenue in 2002?
Your response must be concise. -4.20e+09. What is the difference between the Expenses (in $) of Labor Taxes in 2001 and the Expenses (in $) of Services in 2002?
Your answer should be very brief. -2.19e+09. What is the difference between the Expenses (in $) of Grants and Revenue in 2001 and the Expenses (in $) of Services in 2002?
Offer a terse response. 2.29e+09. What is the difference between the Expenses (in $) in Miscellaneous expenses in 2001 and the Expenses (in $) in Labor Taxes in 2003?
Provide a short and direct response. -6.60e+09. What is the difference between the Expenses (in $) of Miscellaneous expenses in 2001 and the Expenses (in $) of Grants and Revenue in 2003?
Your answer should be very brief. 7.46e+09. What is the difference between the Expenses (in $) of Miscellaneous expenses in 2001 and the Expenses (in $) of Services in 2003?
Provide a succinct answer. 5.88e+09. What is the difference between the Expenses (in $) in Labor Taxes in 2001 and the Expenses (in $) in Grants and Revenue in 2003?
Offer a terse response. -2.78e+09. What is the difference between the Expenses (in $) of Labor Taxes in 2001 and the Expenses (in $) of Services in 2003?
Give a very brief answer. -4.36e+09. What is the difference between the Expenses (in $) in Grants and Revenue in 2001 and the Expenses (in $) in Services in 2003?
Offer a very short reply. 1.14e+08. What is the difference between the Expenses (in $) of Miscellaneous expenses in 2001 and the Expenses (in $) of Labor Taxes in 2004?
Offer a very short reply. 2.60e+07. What is the difference between the Expenses (in $) in Miscellaneous expenses in 2001 and the Expenses (in $) in Grants and Revenue in 2004?
Your response must be concise. 6.50e+09. What is the difference between the Expenses (in $) of Miscellaneous expenses in 2001 and the Expenses (in $) of Services in 2004?
Offer a terse response. 5.40e+09. What is the difference between the Expenses (in $) of Labor Taxes in 2001 and the Expenses (in $) of Grants and Revenue in 2004?
Provide a short and direct response. -3.74e+09. What is the difference between the Expenses (in $) in Labor Taxes in 2001 and the Expenses (in $) in Services in 2004?
Your answer should be very brief. -4.84e+09. What is the difference between the Expenses (in $) of Grants and Revenue in 2001 and the Expenses (in $) of Services in 2004?
Provide a short and direct response. -3.69e+08. What is the difference between the Expenses (in $) in Miscellaneous expenses in 2002 and the Expenses (in $) in Labor Taxes in 2003?
Offer a very short reply. -6.17e+09. What is the difference between the Expenses (in $) in Miscellaneous expenses in 2002 and the Expenses (in $) in Grants and Revenue in 2003?
Your answer should be compact. 7.90e+09. What is the difference between the Expenses (in $) in Miscellaneous expenses in 2002 and the Expenses (in $) in Services in 2003?
Offer a very short reply. 6.32e+09. What is the difference between the Expenses (in $) in Labor Taxes in 2002 and the Expenses (in $) in Grants and Revenue in 2003?
Make the answer very short. 8.02e+08. What is the difference between the Expenses (in $) in Labor Taxes in 2002 and the Expenses (in $) in Services in 2003?
Provide a succinct answer. -7.73e+08. What is the difference between the Expenses (in $) in Grants and Revenue in 2002 and the Expenses (in $) in Services in 2003?
Your answer should be very brief. -1.55e+08. What is the difference between the Expenses (in $) in Miscellaneous expenses in 2002 and the Expenses (in $) in Labor Taxes in 2004?
Ensure brevity in your answer.  4.62e+08. What is the difference between the Expenses (in $) in Miscellaneous expenses in 2002 and the Expenses (in $) in Grants and Revenue in 2004?
Make the answer very short. 6.93e+09. What is the difference between the Expenses (in $) in Miscellaneous expenses in 2002 and the Expenses (in $) in Services in 2004?
Offer a very short reply. 5.84e+09. What is the difference between the Expenses (in $) of Labor Taxes in 2002 and the Expenses (in $) of Grants and Revenue in 2004?
Your response must be concise. -1.59e+08. What is the difference between the Expenses (in $) of Labor Taxes in 2002 and the Expenses (in $) of Services in 2004?
Your answer should be very brief. -1.26e+09. What is the difference between the Expenses (in $) of Grants and Revenue in 2002 and the Expenses (in $) of Services in 2004?
Offer a very short reply. -6.38e+08. What is the difference between the Expenses (in $) of Miscellaneous expenses in 2003 and the Expenses (in $) of Labor Taxes in 2004?
Ensure brevity in your answer.  1.90e+09. What is the difference between the Expenses (in $) in Miscellaneous expenses in 2003 and the Expenses (in $) in Grants and Revenue in 2004?
Make the answer very short. 8.37e+09. What is the difference between the Expenses (in $) in Miscellaneous expenses in 2003 and the Expenses (in $) in Services in 2004?
Your answer should be very brief. 7.27e+09. What is the difference between the Expenses (in $) of Labor Taxes in 2003 and the Expenses (in $) of Grants and Revenue in 2004?
Your answer should be very brief. 1.31e+1. What is the difference between the Expenses (in $) in Labor Taxes in 2003 and the Expenses (in $) in Services in 2004?
Make the answer very short. 1.20e+1. What is the difference between the Expenses (in $) of Grants and Revenue in 2003 and the Expenses (in $) of Services in 2004?
Provide a succinct answer. -2.06e+09. What is the average Expenses (in $) in Miscellaneous expenses per year?
Your response must be concise. 2.55e+1. What is the average Expenses (in $) of Labor Taxes per year?
Your response must be concise. 2.50e+1. What is the average Expenses (in $) in Grants and Revenue per year?
Your answer should be compact. 2.33e+1. What is the average Expenses (in $) of Services per year?
Offer a terse response. 2.07e+1. In the year 1997, what is the difference between the Expenses (in $) in Miscellaneous expenses and Expenses (in $) in Labor Taxes?
Your answer should be very brief. -8.95e+09. In the year 1997, what is the difference between the Expenses (in $) of Miscellaneous expenses and Expenses (in $) of Grants and Revenue?
Your answer should be very brief. -7.49e+09. In the year 1997, what is the difference between the Expenses (in $) of Miscellaneous expenses and Expenses (in $) of Services?
Offer a terse response. -2.90e+08. In the year 1997, what is the difference between the Expenses (in $) in Labor Taxes and Expenses (in $) in Grants and Revenue?
Make the answer very short. 1.46e+09. In the year 1997, what is the difference between the Expenses (in $) of Labor Taxes and Expenses (in $) of Services?
Ensure brevity in your answer.  8.66e+09. In the year 1997, what is the difference between the Expenses (in $) in Grants and Revenue and Expenses (in $) in Services?
Your answer should be compact. 7.20e+09. In the year 1998, what is the difference between the Expenses (in $) in Miscellaneous expenses and Expenses (in $) in Labor Taxes?
Ensure brevity in your answer.  -2.72e+09. In the year 1998, what is the difference between the Expenses (in $) of Miscellaneous expenses and Expenses (in $) of Grants and Revenue?
Your answer should be very brief. -1.40e+09. In the year 1998, what is the difference between the Expenses (in $) of Miscellaneous expenses and Expenses (in $) of Services?
Provide a short and direct response. 3.95e+09. In the year 1998, what is the difference between the Expenses (in $) in Labor Taxes and Expenses (in $) in Grants and Revenue?
Keep it short and to the point. 1.32e+09. In the year 1998, what is the difference between the Expenses (in $) in Labor Taxes and Expenses (in $) in Services?
Provide a short and direct response. 6.67e+09. In the year 1998, what is the difference between the Expenses (in $) in Grants and Revenue and Expenses (in $) in Services?
Give a very brief answer. 5.34e+09. In the year 1999, what is the difference between the Expenses (in $) in Miscellaneous expenses and Expenses (in $) in Labor Taxes?
Keep it short and to the point. 2.42e+09. In the year 1999, what is the difference between the Expenses (in $) of Miscellaneous expenses and Expenses (in $) of Grants and Revenue?
Provide a short and direct response. -2.33e+09. In the year 1999, what is the difference between the Expenses (in $) of Miscellaneous expenses and Expenses (in $) of Services?
Your answer should be very brief. 4.28e+09. In the year 1999, what is the difference between the Expenses (in $) of Labor Taxes and Expenses (in $) of Grants and Revenue?
Ensure brevity in your answer.  -4.75e+09. In the year 1999, what is the difference between the Expenses (in $) in Labor Taxes and Expenses (in $) in Services?
Provide a succinct answer. 1.87e+09. In the year 1999, what is the difference between the Expenses (in $) in Grants and Revenue and Expenses (in $) in Services?
Your answer should be compact. 6.62e+09. In the year 2000, what is the difference between the Expenses (in $) of Miscellaneous expenses and Expenses (in $) of Labor Taxes?
Offer a very short reply. 2.35e+09. In the year 2000, what is the difference between the Expenses (in $) in Miscellaneous expenses and Expenses (in $) in Grants and Revenue?
Offer a very short reply. 2.80e+09. In the year 2000, what is the difference between the Expenses (in $) in Miscellaneous expenses and Expenses (in $) in Services?
Ensure brevity in your answer.  2.56e+09. In the year 2000, what is the difference between the Expenses (in $) of Labor Taxes and Expenses (in $) of Grants and Revenue?
Provide a short and direct response. 4.50e+08. In the year 2000, what is the difference between the Expenses (in $) of Labor Taxes and Expenses (in $) of Services?
Provide a succinct answer. 2.08e+08. In the year 2000, what is the difference between the Expenses (in $) of Grants and Revenue and Expenses (in $) of Services?
Ensure brevity in your answer.  -2.42e+08. In the year 2001, what is the difference between the Expenses (in $) of Miscellaneous expenses and Expenses (in $) of Labor Taxes?
Offer a very short reply. 1.02e+1. In the year 2001, what is the difference between the Expenses (in $) in Miscellaneous expenses and Expenses (in $) in Grants and Revenue?
Offer a terse response. 5.77e+09. In the year 2001, what is the difference between the Expenses (in $) of Miscellaneous expenses and Expenses (in $) of Services?
Provide a short and direct response. 8.74e+09. In the year 2001, what is the difference between the Expenses (in $) in Labor Taxes and Expenses (in $) in Grants and Revenue?
Offer a very short reply. -4.47e+09. In the year 2001, what is the difference between the Expenses (in $) in Labor Taxes and Expenses (in $) in Services?
Make the answer very short. -1.51e+09. In the year 2001, what is the difference between the Expenses (in $) in Grants and Revenue and Expenses (in $) in Services?
Provide a short and direct response. 2.96e+09. In the year 2002, what is the difference between the Expenses (in $) in Miscellaneous expenses and Expenses (in $) in Labor Taxes?
Offer a terse response. 7.09e+09. In the year 2002, what is the difference between the Expenses (in $) in Miscellaneous expenses and Expenses (in $) in Grants and Revenue?
Your answer should be very brief. 6.48e+09. In the year 2002, what is the difference between the Expenses (in $) in Miscellaneous expenses and Expenses (in $) in Services?
Offer a very short reply. 8.49e+09. In the year 2002, what is the difference between the Expenses (in $) in Labor Taxes and Expenses (in $) in Grants and Revenue?
Provide a short and direct response. -6.18e+08. In the year 2002, what is the difference between the Expenses (in $) of Labor Taxes and Expenses (in $) of Services?
Offer a terse response. 1.40e+09. In the year 2002, what is the difference between the Expenses (in $) in Grants and Revenue and Expenses (in $) in Services?
Your answer should be very brief. 2.02e+09. In the year 2003, what is the difference between the Expenses (in $) of Miscellaneous expenses and Expenses (in $) of Labor Taxes?
Your answer should be very brief. -4.73e+09. In the year 2003, what is the difference between the Expenses (in $) of Miscellaneous expenses and Expenses (in $) of Grants and Revenue?
Offer a very short reply. 9.33e+09. In the year 2003, what is the difference between the Expenses (in $) of Miscellaneous expenses and Expenses (in $) of Services?
Provide a short and direct response. 7.76e+09. In the year 2003, what is the difference between the Expenses (in $) in Labor Taxes and Expenses (in $) in Grants and Revenue?
Ensure brevity in your answer.  1.41e+1. In the year 2003, what is the difference between the Expenses (in $) of Labor Taxes and Expenses (in $) of Services?
Offer a very short reply. 1.25e+1. In the year 2003, what is the difference between the Expenses (in $) of Grants and Revenue and Expenses (in $) of Services?
Your answer should be compact. -1.58e+09. In the year 2004, what is the difference between the Expenses (in $) of Miscellaneous expenses and Expenses (in $) of Labor Taxes?
Provide a short and direct response. -2.08e+09. In the year 2004, what is the difference between the Expenses (in $) of Miscellaneous expenses and Expenses (in $) of Grants and Revenue?
Your answer should be compact. 4.39e+09. In the year 2004, what is the difference between the Expenses (in $) of Miscellaneous expenses and Expenses (in $) of Services?
Make the answer very short. 3.29e+09. In the year 2004, what is the difference between the Expenses (in $) in Labor Taxes and Expenses (in $) in Grants and Revenue?
Offer a terse response. 6.47e+09. In the year 2004, what is the difference between the Expenses (in $) in Labor Taxes and Expenses (in $) in Services?
Provide a succinct answer. 5.38e+09. In the year 2004, what is the difference between the Expenses (in $) of Grants and Revenue and Expenses (in $) of Services?
Give a very brief answer. -1.10e+09. What is the ratio of the Expenses (in $) of Miscellaneous expenses in 1997 to that in 1998?
Keep it short and to the point. 0.78. What is the ratio of the Expenses (in $) in Labor Taxes in 1997 to that in 1998?
Offer a very short reply. 1.06. What is the ratio of the Expenses (in $) of Grants and Revenue in 1997 to that in 1998?
Ensure brevity in your answer.  1.06. What is the ratio of the Expenses (in $) in Services in 1997 to that in 1998?
Provide a succinct answer. 0.97. What is the ratio of the Expenses (in $) in Miscellaneous expenses in 1997 to that in 1999?
Your answer should be compact. 0.72. What is the ratio of the Expenses (in $) in Labor Taxes in 1997 to that in 1999?
Give a very brief answer. 1.24. What is the ratio of the Expenses (in $) in Grants and Revenue in 1997 to that in 1999?
Offer a terse response. 0.95. What is the ratio of the Expenses (in $) in Services in 1997 to that in 1999?
Your answer should be very brief. 0.9. What is the ratio of the Expenses (in $) in Miscellaneous expenses in 1997 to that in 2000?
Your response must be concise. 0.73. What is the ratio of the Expenses (in $) of Labor Taxes in 1997 to that in 2000?
Your response must be concise. 1.25. What is the ratio of the Expenses (in $) in Grants and Revenue in 1997 to that in 2000?
Give a very brief answer. 1.21. What is the ratio of the Expenses (in $) in Services in 1997 to that in 2000?
Make the answer very short. 0.84. What is the ratio of the Expenses (in $) of Miscellaneous expenses in 1997 to that in 2001?
Keep it short and to the point. 0.56. What is the ratio of the Expenses (in $) in Labor Taxes in 1997 to that in 2001?
Provide a succinct answer. 1.31. What is the ratio of the Expenses (in $) of Grants and Revenue in 1997 to that in 2001?
Your answer should be compact. 1.01. What is the ratio of the Expenses (in $) in Services in 1997 to that in 2001?
Provide a short and direct response. 0.81. What is the ratio of the Expenses (in $) in Miscellaneous expenses in 1997 to that in 2002?
Your answer should be compact. 0.56. What is the ratio of the Expenses (in $) of Labor Taxes in 1997 to that in 2002?
Your answer should be compact. 1.11. What is the ratio of the Expenses (in $) in Grants and Revenue in 1997 to that in 2002?
Keep it short and to the point. 1.02. What is the ratio of the Expenses (in $) in Services in 1997 to that in 2002?
Your response must be concise. 0.78. What is the ratio of the Expenses (in $) in Miscellaneous expenses in 1997 to that in 2003?
Ensure brevity in your answer.  0.53. What is the ratio of the Expenses (in $) in Labor Taxes in 1997 to that in 2003?
Give a very brief answer. 0.71. What is the ratio of the Expenses (in $) in Grants and Revenue in 1997 to that in 2003?
Make the answer very short. 1.09. What is the ratio of the Expenses (in $) of Services in 1997 to that in 2003?
Provide a short and direct response. 0.71. What is the ratio of the Expenses (in $) in Miscellaneous expenses in 1997 to that in 2004?
Offer a very short reply. 0.61. What is the ratio of the Expenses (in $) of Labor Taxes in 1997 to that in 2004?
Provide a succinct answer. 0.86. What is the ratio of the Expenses (in $) of Grants and Revenue in 1997 to that in 2004?
Offer a terse response. 1.04. What is the ratio of the Expenses (in $) in Services in 1997 to that in 2004?
Make the answer very short. 0.7. What is the ratio of the Expenses (in $) of Miscellaneous expenses in 1998 to that in 1999?
Offer a very short reply. 0.93. What is the ratio of the Expenses (in $) of Labor Taxes in 1998 to that in 1999?
Make the answer very short. 1.16. What is the ratio of the Expenses (in $) of Grants and Revenue in 1998 to that in 1999?
Your answer should be very brief. 0.9. What is the ratio of the Expenses (in $) in Services in 1998 to that in 1999?
Keep it short and to the point. 0.93. What is the ratio of the Expenses (in $) of Miscellaneous expenses in 1998 to that in 2000?
Ensure brevity in your answer.  0.94. What is the ratio of the Expenses (in $) in Labor Taxes in 1998 to that in 2000?
Offer a terse response. 1.18. What is the ratio of the Expenses (in $) in Grants and Revenue in 1998 to that in 2000?
Keep it short and to the point. 1.14. What is the ratio of the Expenses (in $) of Services in 1998 to that in 2000?
Make the answer very short. 0.86. What is the ratio of the Expenses (in $) in Miscellaneous expenses in 1998 to that in 2001?
Offer a terse response. 0.72. What is the ratio of the Expenses (in $) of Labor Taxes in 1998 to that in 2001?
Provide a succinct answer. 1.24. What is the ratio of the Expenses (in $) in Grants and Revenue in 1998 to that in 2001?
Give a very brief answer. 0.95. What is the ratio of the Expenses (in $) of Services in 1998 to that in 2001?
Keep it short and to the point. 0.83. What is the ratio of the Expenses (in $) of Miscellaneous expenses in 1998 to that in 2002?
Your response must be concise. 0.71. What is the ratio of the Expenses (in $) in Labor Taxes in 1998 to that in 2002?
Give a very brief answer. 1.04. What is the ratio of the Expenses (in $) in Grants and Revenue in 1998 to that in 2002?
Your answer should be compact. 0.96. What is the ratio of the Expenses (in $) in Services in 1998 to that in 2002?
Give a very brief answer. 0.81. What is the ratio of the Expenses (in $) in Miscellaneous expenses in 1998 to that in 2003?
Offer a very short reply. 0.68. What is the ratio of the Expenses (in $) in Labor Taxes in 1998 to that in 2003?
Your answer should be compact. 0.66. What is the ratio of the Expenses (in $) of Grants and Revenue in 1998 to that in 2003?
Keep it short and to the point. 1.02. What is the ratio of the Expenses (in $) in Services in 1998 to that in 2003?
Provide a short and direct response. 0.73. What is the ratio of the Expenses (in $) of Miscellaneous expenses in 1998 to that in 2004?
Your answer should be very brief. 0.78. What is the ratio of the Expenses (in $) of Labor Taxes in 1998 to that in 2004?
Make the answer very short. 0.81. What is the ratio of the Expenses (in $) of Grants and Revenue in 1998 to that in 2004?
Provide a short and direct response. 0.98. What is the ratio of the Expenses (in $) of Services in 1998 to that in 2004?
Provide a succinct answer. 0.72. What is the ratio of the Expenses (in $) in Miscellaneous expenses in 1999 to that in 2000?
Ensure brevity in your answer.  1.01. What is the ratio of the Expenses (in $) in Labor Taxes in 1999 to that in 2000?
Your answer should be compact. 1.01. What is the ratio of the Expenses (in $) of Grants and Revenue in 1999 to that in 2000?
Provide a short and direct response. 1.27. What is the ratio of the Expenses (in $) of Services in 1999 to that in 2000?
Give a very brief answer. 0.93. What is the ratio of the Expenses (in $) of Miscellaneous expenses in 1999 to that in 2001?
Provide a succinct answer. 0.78. What is the ratio of the Expenses (in $) in Labor Taxes in 1999 to that in 2001?
Give a very brief answer. 1.06. What is the ratio of the Expenses (in $) of Grants and Revenue in 1999 to that in 2001?
Provide a short and direct response. 1.06. What is the ratio of the Expenses (in $) of Services in 1999 to that in 2001?
Give a very brief answer. 0.9. What is the ratio of the Expenses (in $) of Miscellaneous expenses in 1999 to that in 2002?
Offer a terse response. 0.77. What is the ratio of the Expenses (in $) of Labor Taxes in 1999 to that in 2002?
Offer a very short reply. 0.9. What is the ratio of the Expenses (in $) of Grants and Revenue in 1999 to that in 2002?
Offer a very short reply. 1.07. What is the ratio of the Expenses (in $) of Services in 1999 to that in 2002?
Give a very brief answer. 0.87. What is the ratio of the Expenses (in $) in Miscellaneous expenses in 1999 to that in 2003?
Your answer should be compact. 0.73. What is the ratio of the Expenses (in $) in Labor Taxes in 1999 to that in 2003?
Your answer should be very brief. 0.57. What is the ratio of the Expenses (in $) in Grants and Revenue in 1999 to that in 2003?
Your answer should be compact. 1.14. What is the ratio of the Expenses (in $) of Services in 1999 to that in 2003?
Make the answer very short. 0.79. What is the ratio of the Expenses (in $) of Miscellaneous expenses in 1999 to that in 2004?
Your response must be concise. 0.84. What is the ratio of the Expenses (in $) of Labor Taxes in 1999 to that in 2004?
Provide a succinct answer. 0.7. What is the ratio of the Expenses (in $) in Grants and Revenue in 1999 to that in 2004?
Your response must be concise. 1.1. What is the ratio of the Expenses (in $) of Services in 1999 to that in 2004?
Your response must be concise. 0.78. What is the ratio of the Expenses (in $) of Miscellaneous expenses in 2000 to that in 2001?
Offer a very short reply. 0.77. What is the ratio of the Expenses (in $) in Labor Taxes in 2000 to that in 2001?
Your response must be concise. 1.05. What is the ratio of the Expenses (in $) in Grants and Revenue in 2000 to that in 2001?
Your answer should be very brief. 0.83. What is the ratio of the Expenses (in $) of Services in 2000 to that in 2001?
Your answer should be compact. 0.96. What is the ratio of the Expenses (in $) of Miscellaneous expenses in 2000 to that in 2002?
Provide a succinct answer. 0.76. What is the ratio of the Expenses (in $) of Labor Taxes in 2000 to that in 2002?
Your answer should be very brief. 0.89. What is the ratio of the Expenses (in $) of Grants and Revenue in 2000 to that in 2002?
Your answer should be very brief. 0.84. What is the ratio of the Expenses (in $) in Services in 2000 to that in 2002?
Provide a succinct answer. 0.93. What is the ratio of the Expenses (in $) of Miscellaneous expenses in 2000 to that in 2003?
Keep it short and to the point. 0.72. What is the ratio of the Expenses (in $) of Labor Taxes in 2000 to that in 2003?
Ensure brevity in your answer.  0.56. What is the ratio of the Expenses (in $) of Grants and Revenue in 2000 to that in 2003?
Ensure brevity in your answer.  0.9. What is the ratio of the Expenses (in $) of Services in 2000 to that in 2003?
Your answer should be compact. 0.85. What is the ratio of the Expenses (in $) in Miscellaneous expenses in 2000 to that in 2004?
Offer a terse response. 0.83. What is the ratio of the Expenses (in $) in Labor Taxes in 2000 to that in 2004?
Your answer should be very brief. 0.69. What is the ratio of the Expenses (in $) of Grants and Revenue in 2000 to that in 2004?
Keep it short and to the point. 0.86. What is the ratio of the Expenses (in $) of Services in 2000 to that in 2004?
Provide a short and direct response. 0.83. What is the ratio of the Expenses (in $) of Miscellaneous expenses in 2001 to that in 2002?
Provide a short and direct response. 0.99. What is the ratio of the Expenses (in $) of Labor Taxes in 2001 to that in 2002?
Offer a terse response. 0.85. What is the ratio of the Expenses (in $) in Grants and Revenue in 2001 to that in 2002?
Provide a short and direct response. 1.01. What is the ratio of the Expenses (in $) of Services in 2001 to that in 2002?
Provide a short and direct response. 0.97. What is the ratio of the Expenses (in $) of Miscellaneous expenses in 2001 to that in 2003?
Make the answer very short. 0.94. What is the ratio of the Expenses (in $) in Labor Taxes in 2001 to that in 2003?
Offer a very short reply. 0.54. What is the ratio of the Expenses (in $) in Grants and Revenue in 2001 to that in 2003?
Ensure brevity in your answer.  1.08. What is the ratio of the Expenses (in $) in Services in 2001 to that in 2003?
Keep it short and to the point. 0.88. What is the ratio of the Expenses (in $) in Miscellaneous expenses in 2001 to that in 2004?
Give a very brief answer. 1.08. What is the ratio of the Expenses (in $) in Labor Taxes in 2001 to that in 2004?
Provide a succinct answer. 0.66. What is the ratio of the Expenses (in $) in Grants and Revenue in 2001 to that in 2004?
Make the answer very short. 1.03. What is the ratio of the Expenses (in $) of Services in 2001 to that in 2004?
Your answer should be compact. 0.86. What is the ratio of the Expenses (in $) in Miscellaneous expenses in 2002 to that in 2003?
Your answer should be compact. 0.95. What is the ratio of the Expenses (in $) in Labor Taxes in 2002 to that in 2003?
Your answer should be compact. 0.64. What is the ratio of the Expenses (in $) of Grants and Revenue in 2002 to that in 2003?
Provide a short and direct response. 1.06. What is the ratio of the Expenses (in $) of Services in 2002 to that in 2003?
Make the answer very short. 0.91. What is the ratio of the Expenses (in $) of Miscellaneous expenses in 2002 to that in 2004?
Keep it short and to the point. 1.09. What is the ratio of the Expenses (in $) of Labor Taxes in 2002 to that in 2004?
Provide a short and direct response. 0.78. What is the ratio of the Expenses (in $) of Grants and Revenue in 2002 to that in 2004?
Your answer should be very brief. 1.02. What is the ratio of the Expenses (in $) in Services in 2002 to that in 2004?
Your response must be concise. 0.89. What is the ratio of the Expenses (in $) of Miscellaneous expenses in 2003 to that in 2004?
Make the answer very short. 1.14. What is the ratio of the Expenses (in $) of Labor Taxes in 2003 to that in 2004?
Keep it short and to the point. 1.22. What is the ratio of the Expenses (in $) of Grants and Revenue in 2003 to that in 2004?
Your response must be concise. 0.96. What is the ratio of the Expenses (in $) of Services in 2003 to that in 2004?
Provide a short and direct response. 0.98. What is the difference between the highest and the second highest Expenses (in $) in Miscellaneous expenses?
Your response must be concise. 1.44e+09. What is the difference between the highest and the second highest Expenses (in $) in Labor Taxes?
Make the answer very short. 6.63e+09. What is the difference between the highest and the second highest Expenses (in $) of Grants and Revenue?
Offer a terse response. 1.27e+09. What is the difference between the highest and the second highest Expenses (in $) in Services?
Give a very brief answer. 4.83e+08. What is the difference between the highest and the lowest Expenses (in $) of Miscellaneous expenses?
Keep it short and to the point. 1.49e+1. What is the difference between the highest and the lowest Expenses (in $) of Labor Taxes?
Keep it short and to the point. 1.68e+1. What is the difference between the highest and the lowest Expenses (in $) in Grants and Revenue?
Offer a terse response. 5.48e+09. What is the difference between the highest and the lowest Expenses (in $) in Services?
Offer a terse response. 7.34e+09. 